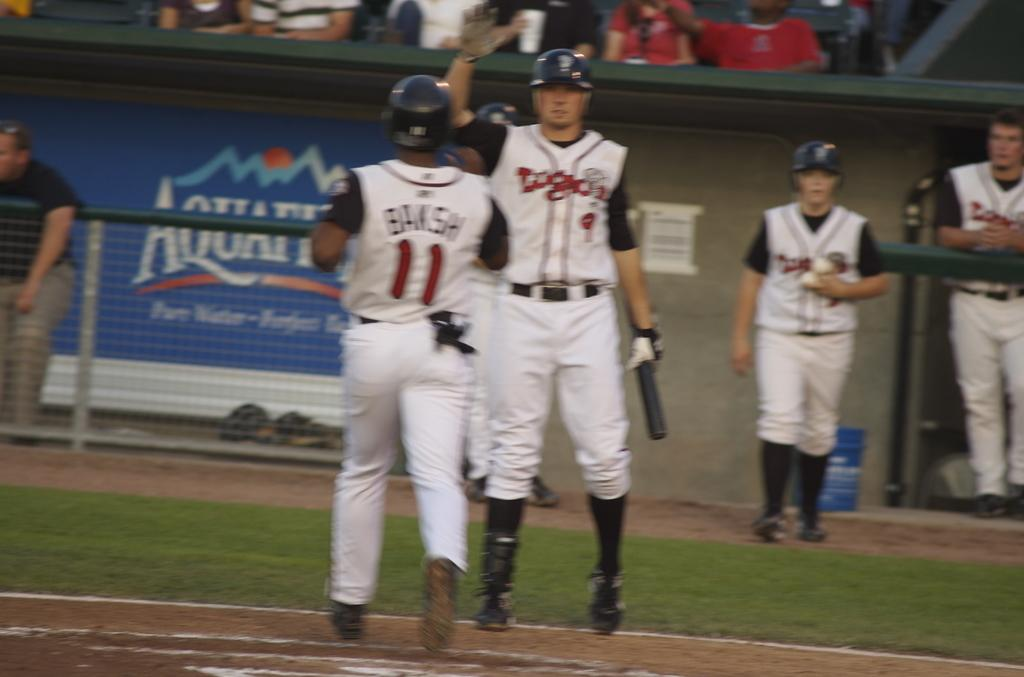<image>
Create a compact narrative representing the image presented. An Aquafina advertisement is visible on the wall behind two baseball players. 